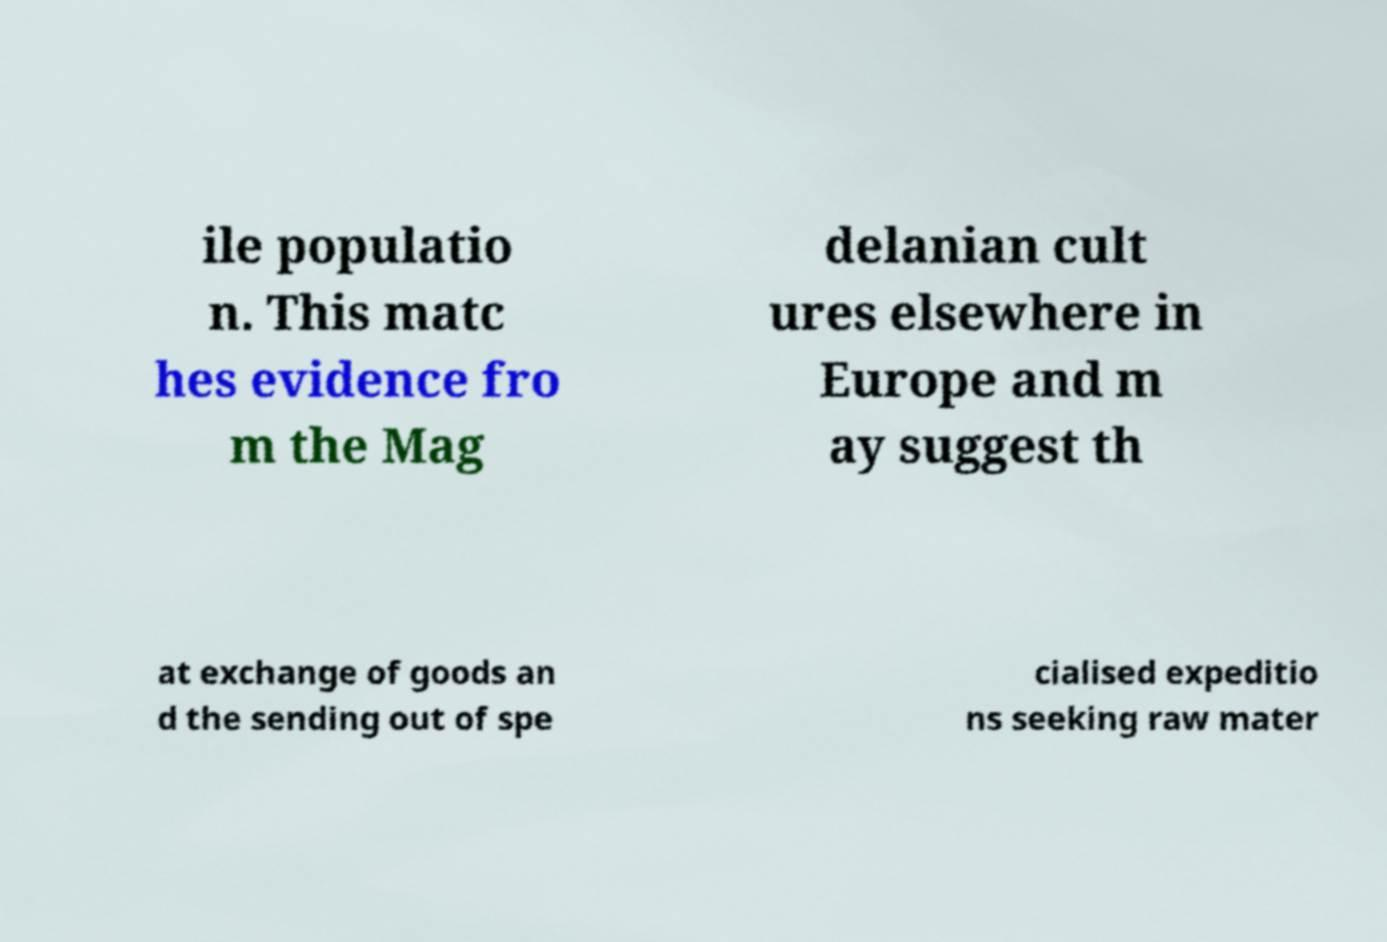Could you assist in decoding the text presented in this image and type it out clearly? ile populatio n. This matc hes evidence fro m the Mag delanian cult ures elsewhere in Europe and m ay suggest th at exchange of goods an d the sending out of spe cialised expeditio ns seeking raw mater 